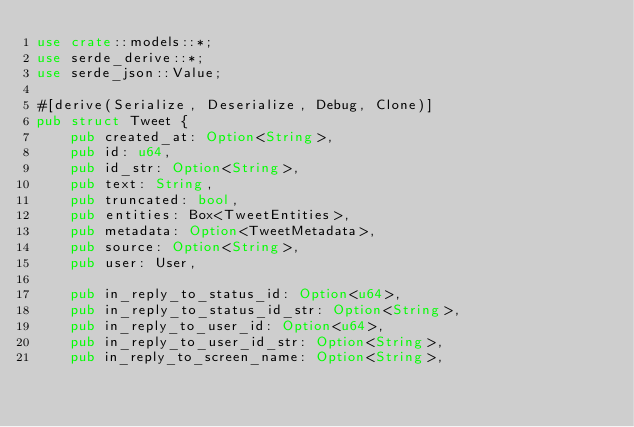Convert code to text. <code><loc_0><loc_0><loc_500><loc_500><_Rust_>use crate::models::*;
use serde_derive::*;
use serde_json::Value;

#[derive(Serialize, Deserialize, Debug, Clone)]
pub struct Tweet {
    pub created_at: Option<String>,
    pub id: u64,
    pub id_str: Option<String>,
    pub text: String,
    pub truncated: bool,
    pub entities: Box<TweetEntities>,
    pub metadata: Option<TweetMetadata>,
    pub source: Option<String>,
    pub user: User,

    pub in_reply_to_status_id: Option<u64>,
    pub in_reply_to_status_id_str: Option<String>,
    pub in_reply_to_user_id: Option<u64>,
    pub in_reply_to_user_id_str: Option<String>,
    pub in_reply_to_screen_name: Option<String>,
</code> 